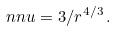Convert formula to latex. <formula><loc_0><loc_0><loc_500><loc_500>\ n n u = 3 / r ^ { 4 / 3 } \, .</formula> 